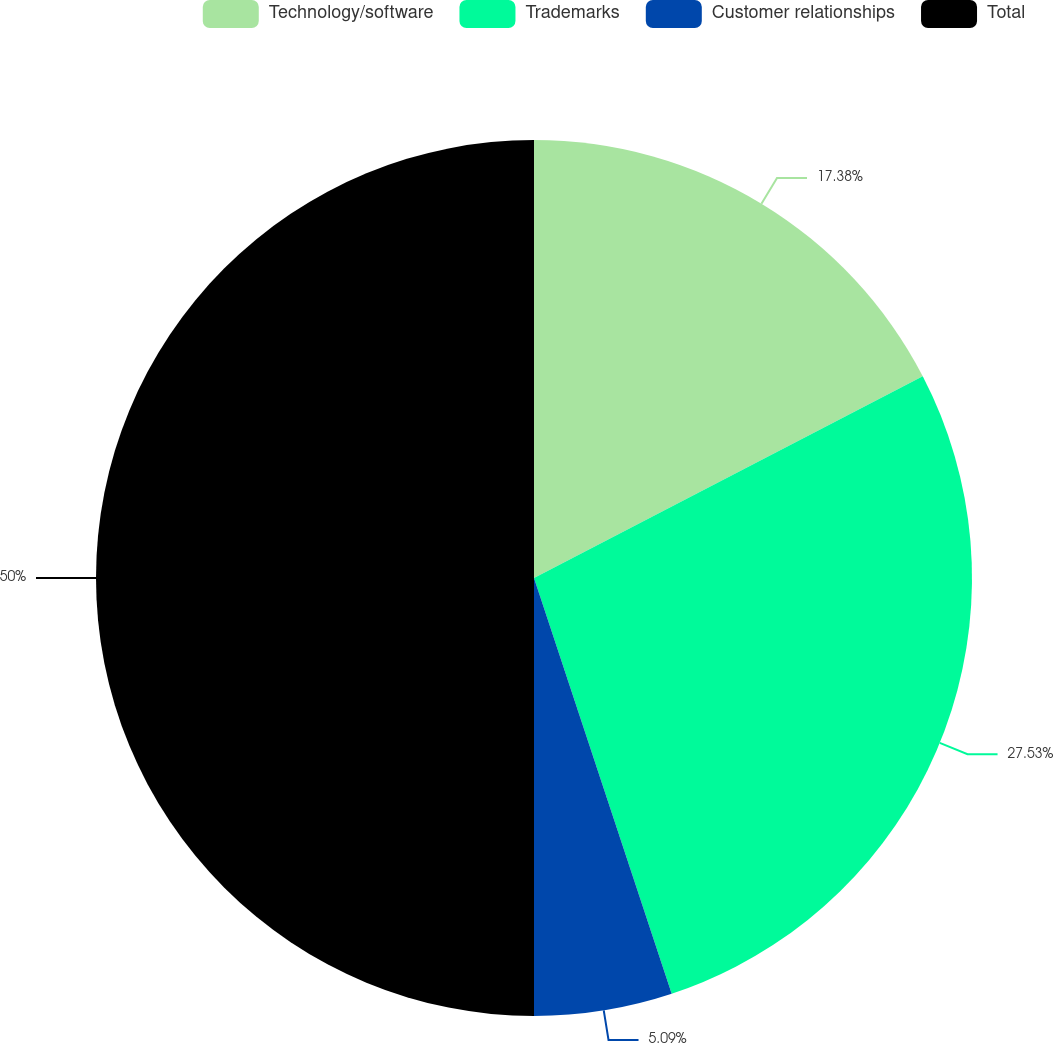Convert chart. <chart><loc_0><loc_0><loc_500><loc_500><pie_chart><fcel>Technology/software<fcel>Trademarks<fcel>Customer relationships<fcel>Total<nl><fcel>17.38%<fcel>27.53%<fcel>5.09%<fcel>50.0%<nl></chart> 